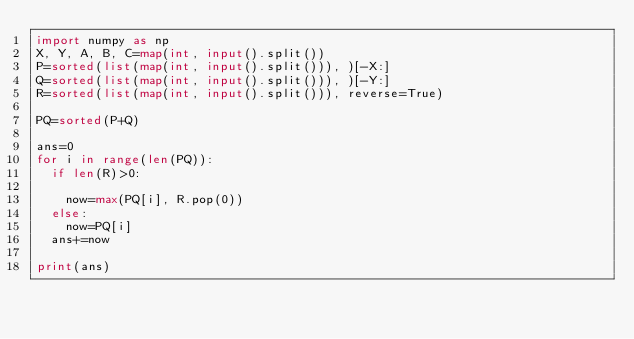Convert code to text. <code><loc_0><loc_0><loc_500><loc_500><_Python_>import numpy as np
X, Y, A, B, C=map(int, input().split())
P=sorted(list(map(int, input().split())), )[-X:]
Q=sorted(list(map(int, input().split())), )[-Y:]
R=sorted(list(map(int, input().split())), reverse=True)

PQ=sorted(P+Q)

ans=0
for i in range(len(PQ)):
  if len(R)>0:
    
    now=max(PQ[i], R.pop(0))
  else:
    now=PQ[i]
  ans+=now
  
print(ans)</code> 